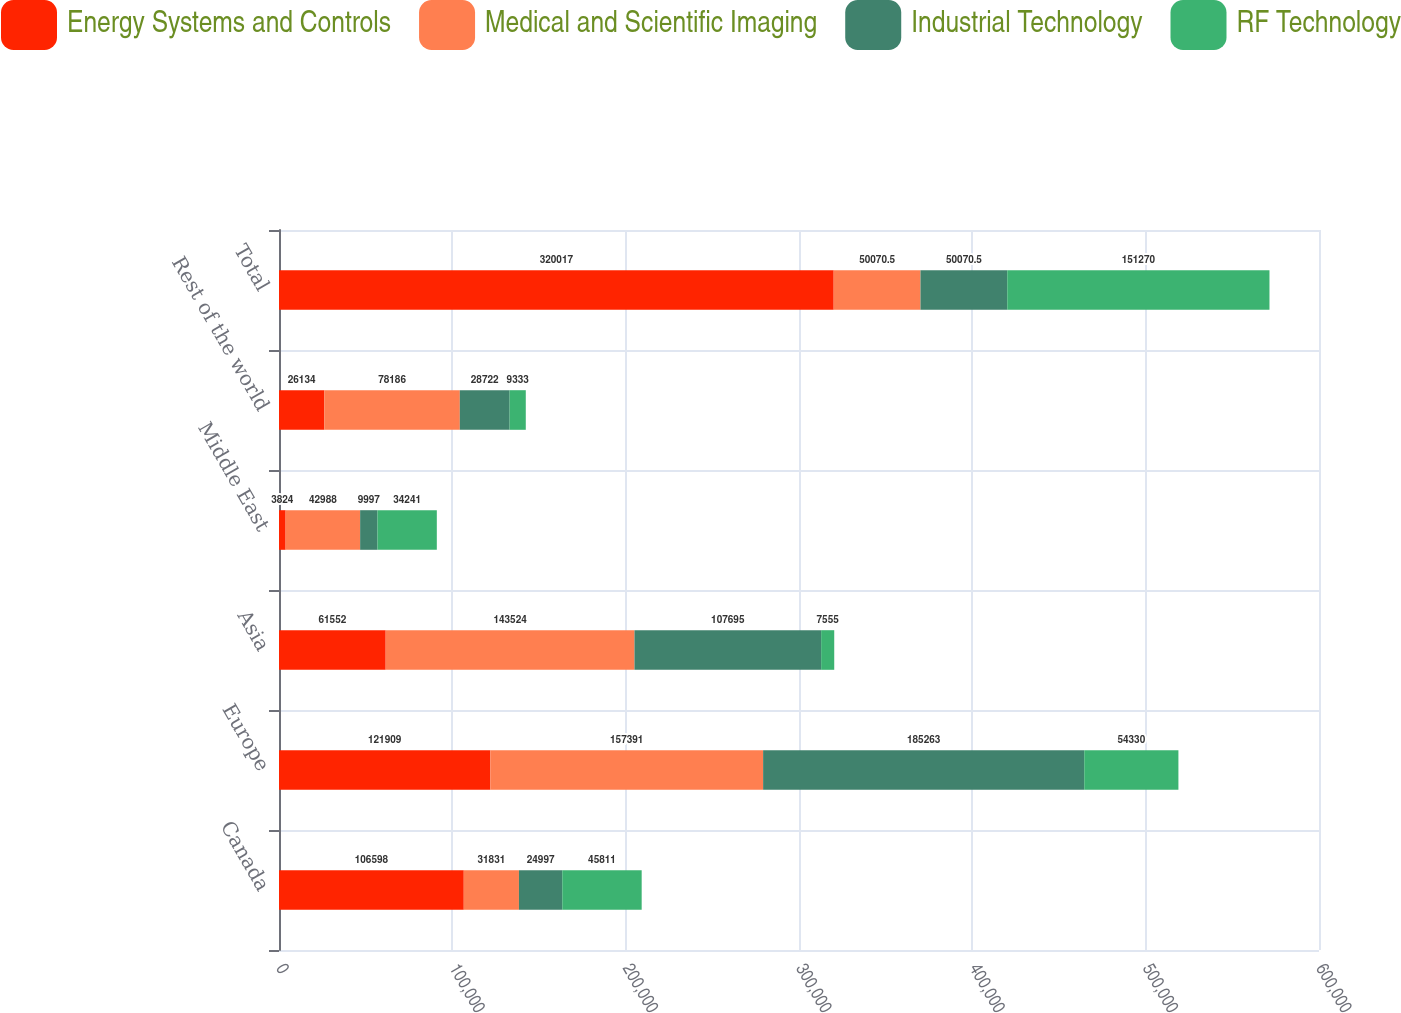Convert chart to OTSL. <chart><loc_0><loc_0><loc_500><loc_500><stacked_bar_chart><ecel><fcel>Canada<fcel>Europe<fcel>Asia<fcel>Middle East<fcel>Rest of the world<fcel>Total<nl><fcel>Energy Systems and Controls<fcel>106598<fcel>121909<fcel>61552<fcel>3824<fcel>26134<fcel>320017<nl><fcel>Medical and Scientific Imaging<fcel>31831<fcel>157391<fcel>143524<fcel>42988<fcel>78186<fcel>50070.5<nl><fcel>Industrial Technology<fcel>24997<fcel>185263<fcel>107695<fcel>9997<fcel>28722<fcel>50070.5<nl><fcel>RF Technology<fcel>45811<fcel>54330<fcel>7555<fcel>34241<fcel>9333<fcel>151270<nl></chart> 